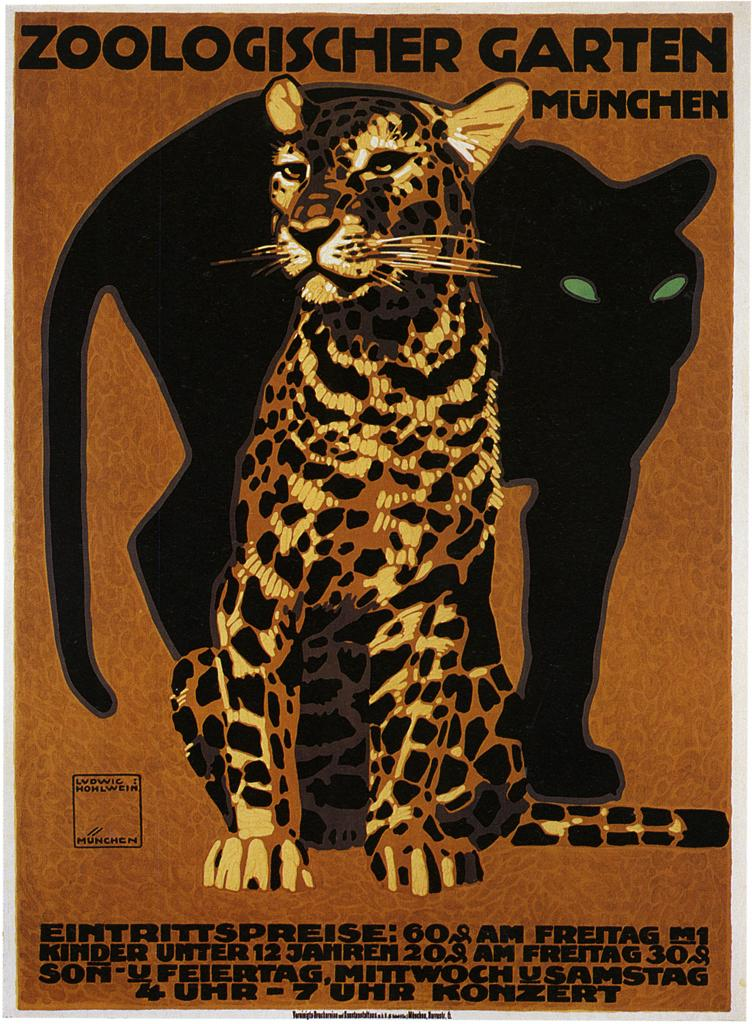What animal can be seen in the picture? There is a leopard in the picture. What else is present in the picture besides the leopard? There is some text visible in the picture. What type of trousers is the leopard wearing in the picture? The leopard is an animal and does not wear trousers. --- Facts: 1. There is a person holding a camera in the image. 2. The person is standing on a bridge. 3. There is a river below the bridge. 4. The sky is visible in the image. Absurd Topics: parrot, bicycle, umbrella Conversation: What is the person in the image holding? The person in the image is holding a camera. Where is the person standing in the image? The person is standing on a bridge. What can be seen below the bridge in the image? There is a river below the bridge. What is visible in the background of the image? The sky is visible in the image. Reasoning: Let's think step by step in order to produce the conversation. We start by identifying the main subject in the image, which is the person holding a camera. Then, we expand the conversation to include other items that are also visible, such as the bridge, the river, and the sky. Each question is designed to elicit a specific detail about the image that is known from the provided facts. Absurd Question/Answer: What color is the parrot sitting on the bicycle in the image? There is no parrot or bicycle present in the image. --- Facts: 1. There is a group of people sitting on a bench in the image. 2. The people are holding musical instruments. 3. There is a building in the background of the image. 4. The ground is visible in the image. Absurd Topics: elephant, balloon, hat Conversation: What are the people in the image doing? The people in the image are sitting on a bench and holding musical instruments. What can be seen in the background of the image? There is a building in the background of the image. What is visible beneath the people in the image? The ground is visible in the image. Reasoning: Let's think step by step in order to produce the conversation. We start by identifying the main subject in the image, which is the group of people sitting on a bench. Then, we expand the conversation to include other items that are also visible, such as the musical instruments, the building in the background, and the ground. Each question is designed to elicit a specific detail about the image that is known from the provided facts. Absurd Question/Answer: What type of hat is the elephant wearing in the image? There is no elephant or hat present in the image. --- F 